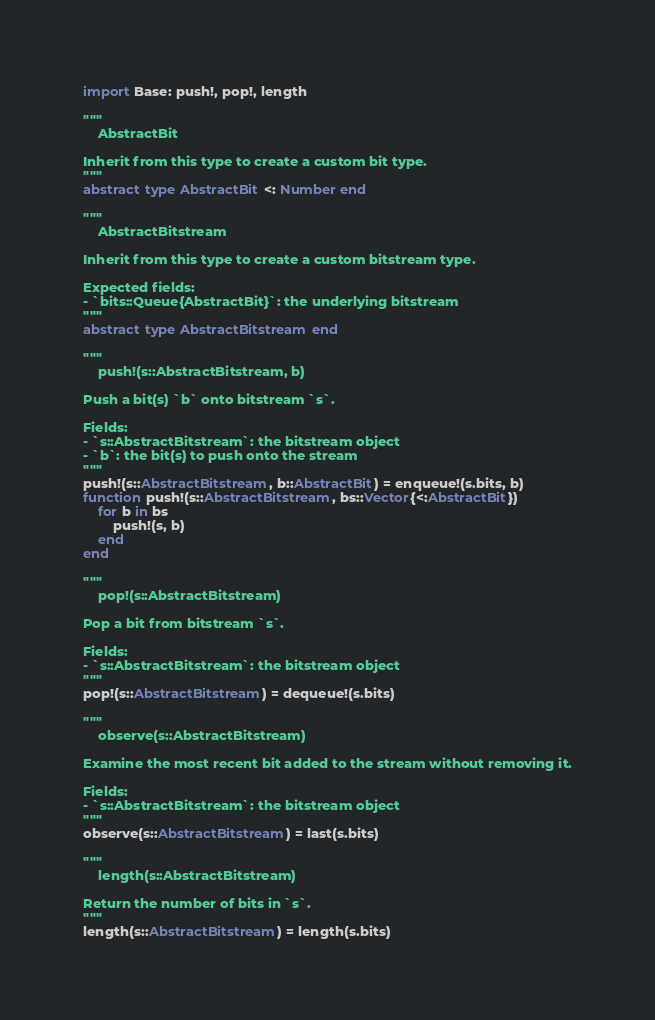<code> <loc_0><loc_0><loc_500><loc_500><_Julia_>import Base: push!, pop!, length

"""
    AbstractBit

Inherit from this type to create a custom bit type.
"""
abstract type AbstractBit <: Number end

"""
    AbstractBitstream

Inherit from this type to create a custom bitstream type.

Expected fields:
- `bits::Queue{AbstractBit}`: the underlying bitstream
"""
abstract type AbstractBitstream end

"""
    push!(s::AbstractBitstream, b)

Push a bit(s) `b` onto bitstream `s`.

Fields:
- `s::AbstractBitstream`: the bitstream object
- `b`: the bit(s) to push onto the stream
"""
push!(s::AbstractBitstream, b::AbstractBit) = enqueue!(s.bits, b)
function push!(s::AbstractBitstream, bs::Vector{<:AbstractBit})
    for b in bs
        push!(s, b)
    end
end

"""
    pop!(s::AbstractBitstream)

Pop a bit from bitstream `s`.

Fields:
- `s::AbstractBitstream`: the bitstream object
"""
pop!(s::AbstractBitstream) = dequeue!(s.bits)

"""
    observe(s::AbstractBitstream)

Examine the most recent bit added to the stream without removing it.

Fields:
- `s::AbstractBitstream`: the bitstream object
"""
observe(s::AbstractBitstream) = last(s.bits)

"""
    length(s::AbstractBitstream)

Return the number of bits in `s`.
"""
length(s::AbstractBitstream) = length(s.bits)</code> 